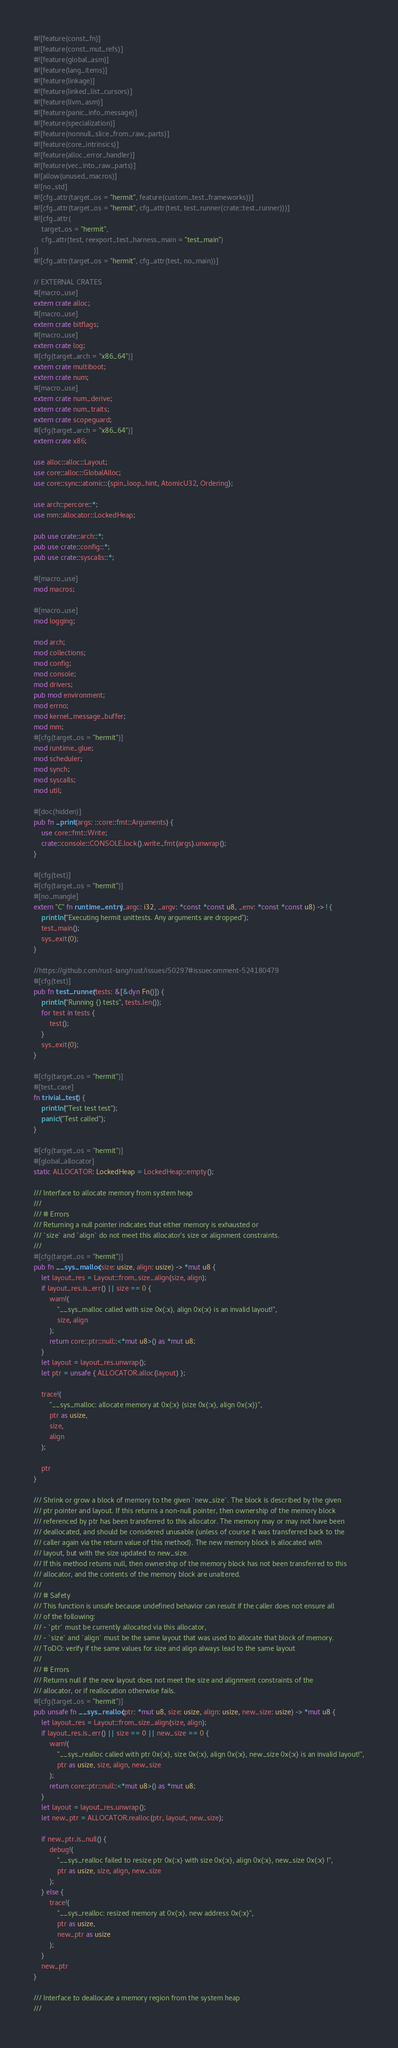<code> <loc_0><loc_0><loc_500><loc_500><_Rust_>#![feature(const_fn)]
#![feature(const_mut_refs)]
#![feature(global_asm)]
#![feature(lang_items)]
#![feature(linkage)]
#![feature(linked_list_cursors)]
#![feature(llvm_asm)]
#![feature(panic_info_message)]
#![feature(specialization)]
#![feature(nonnull_slice_from_raw_parts)]
#![feature(core_intrinsics)]
#![feature(alloc_error_handler)]
#![feature(vec_into_raw_parts)]
#![allow(unused_macros)]
#![no_std]
#![cfg_attr(target_os = "hermit", feature(custom_test_frameworks))]
#![cfg_attr(target_os = "hermit", cfg_attr(test, test_runner(crate::test_runner)))]
#![cfg_attr(
	target_os = "hermit",
	cfg_attr(test, reexport_test_harness_main = "test_main")
)]
#![cfg_attr(target_os = "hermit", cfg_attr(test, no_main))]

// EXTERNAL CRATES
#[macro_use]
extern crate alloc;
#[macro_use]
extern crate bitflags;
#[macro_use]
extern crate log;
#[cfg(target_arch = "x86_64")]
extern crate multiboot;
extern crate num;
#[macro_use]
extern crate num_derive;
extern crate num_traits;
extern crate scopeguard;
#[cfg(target_arch = "x86_64")]
extern crate x86;

use alloc::alloc::Layout;
use core::alloc::GlobalAlloc;
use core::sync::atomic::{spin_loop_hint, AtomicU32, Ordering};

use arch::percore::*;
use mm::allocator::LockedHeap;

pub use crate::arch::*;
pub use crate::config::*;
pub use crate::syscalls::*;

#[macro_use]
mod macros;

#[macro_use]
mod logging;

mod arch;
mod collections;
mod config;
mod console;
mod drivers;
pub mod environment;
mod errno;
mod kernel_message_buffer;
mod mm;
#[cfg(target_os = "hermit")]
mod runtime_glue;
mod scheduler;
mod synch;
mod syscalls;
mod util;

#[doc(hidden)]
pub fn _print(args: ::core::fmt::Arguments) {
	use core::fmt::Write;
	crate::console::CONSOLE.lock().write_fmt(args).unwrap();
}

#[cfg(test)]
#[cfg(target_os = "hermit")]
#[no_mangle]
extern "C" fn runtime_entry(_argc: i32, _argv: *const *const u8, _env: *const *const u8) -> ! {
	println!("Executing hermit unittests. Any arguments are dropped");
	test_main();
	sys_exit(0);
}

//https://github.com/rust-lang/rust/issues/50297#issuecomment-524180479
#[cfg(test)]
pub fn test_runner(tests: &[&dyn Fn()]) {
	println!("Running {} tests", tests.len());
	for test in tests {
		test();
	}
	sys_exit(0);
}

#[cfg(target_os = "hermit")]
#[test_case]
fn trivial_test() {
	println!("Test test test");
	panic!("Test called");
}

#[cfg(target_os = "hermit")]
#[global_allocator]
static ALLOCATOR: LockedHeap = LockedHeap::empty();

/// Interface to allocate memory from system heap
///
/// # Errors
/// Returning a null pointer indicates that either memory is exhausted or
/// `size` and `align` do not meet this allocator's size or alignment constraints.
///
#[cfg(target_os = "hermit")]
pub fn __sys_malloc(size: usize, align: usize) -> *mut u8 {
	let layout_res = Layout::from_size_align(size, align);
	if layout_res.is_err() || size == 0 {
		warn!(
			"__sys_malloc called with size 0x{:x}, align 0x{:x} is an invalid layout!",
			size, align
		);
		return core::ptr::null::<*mut u8>() as *mut u8;
	}
	let layout = layout_res.unwrap();
	let ptr = unsafe { ALLOCATOR.alloc(layout) };

	trace!(
		"__sys_malloc: allocate memory at 0x{:x} (size 0x{:x}, align 0x{:x})",
		ptr as usize,
		size,
		align
	);

	ptr
}

/// Shrink or grow a block of memory to the given `new_size`. The block is described by the given
/// ptr pointer and layout. If this returns a non-null pointer, then ownership of the memory block
/// referenced by ptr has been transferred to this allocator. The memory may or may not have been
/// deallocated, and should be considered unusable (unless of course it was transferred back to the
/// caller again via the return value of this method). The new memory block is allocated with
/// layout, but with the size updated to new_size.
/// If this method returns null, then ownership of the memory block has not been transferred to this
/// allocator, and the contents of the memory block are unaltered.
///
/// # Safety
/// This function is unsafe because undefined behavior can result if the caller does not ensure all
/// of the following:
/// - `ptr` must be currently allocated via this allocator,
/// - `size` and `align` must be the same layout that was used to allocate that block of memory.
/// ToDO: verify if the same values for size and align always lead to the same layout
///
/// # Errors
/// Returns null if the new layout does not meet the size and alignment constraints of the
/// allocator, or if reallocation otherwise fails.
#[cfg(target_os = "hermit")]
pub unsafe fn __sys_realloc(ptr: *mut u8, size: usize, align: usize, new_size: usize) -> *mut u8 {
	let layout_res = Layout::from_size_align(size, align);
	if layout_res.is_err() || size == 0 || new_size == 0 {
		warn!(
			"__sys_realloc called with ptr 0x{:x}, size 0x{:x}, align 0x{:x}, new_size 0x{:x} is an invalid layout!",
			ptr as usize, size, align, new_size
		);
		return core::ptr::null::<*mut u8>() as *mut u8;
	}
	let layout = layout_res.unwrap();
	let new_ptr = ALLOCATOR.realloc(ptr, layout, new_size);

	if new_ptr.is_null() {
		debug!(
			"__sys_realloc failed to resize ptr 0x{:x} with size 0x{:x}, align 0x{:x}, new_size 0x{:x} !",
			ptr as usize, size, align, new_size
		);
	} else {
		trace!(
			"__sys_realloc: resized memory at 0x{:x}, new address 0x{:x}",
			ptr as usize,
			new_ptr as usize
		);
	}
	new_ptr
}

/// Interface to deallocate a memory region from the system heap
///</code> 